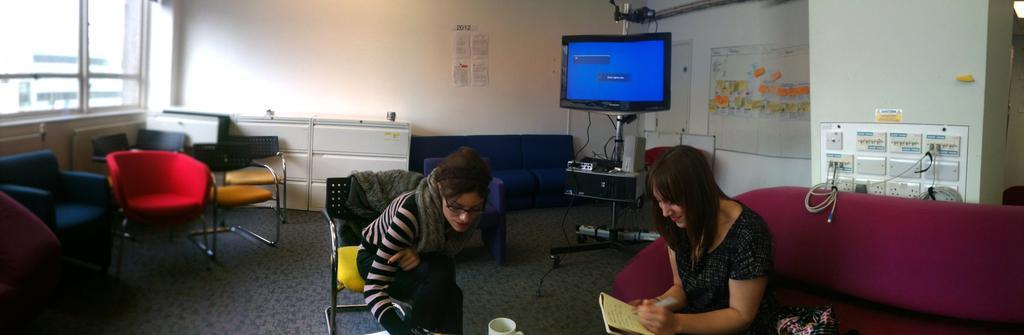Describe this image in one or two sentences. In this image i can see 2 women sitting, a woman on the right side is sitting on the couch and the woman on the left side is sitting on the chair. The woman on the right side is holding a pen and book in her hand. In the background i can see few chairs, the wall, the window, a television screen, few posters and the switch boards. 